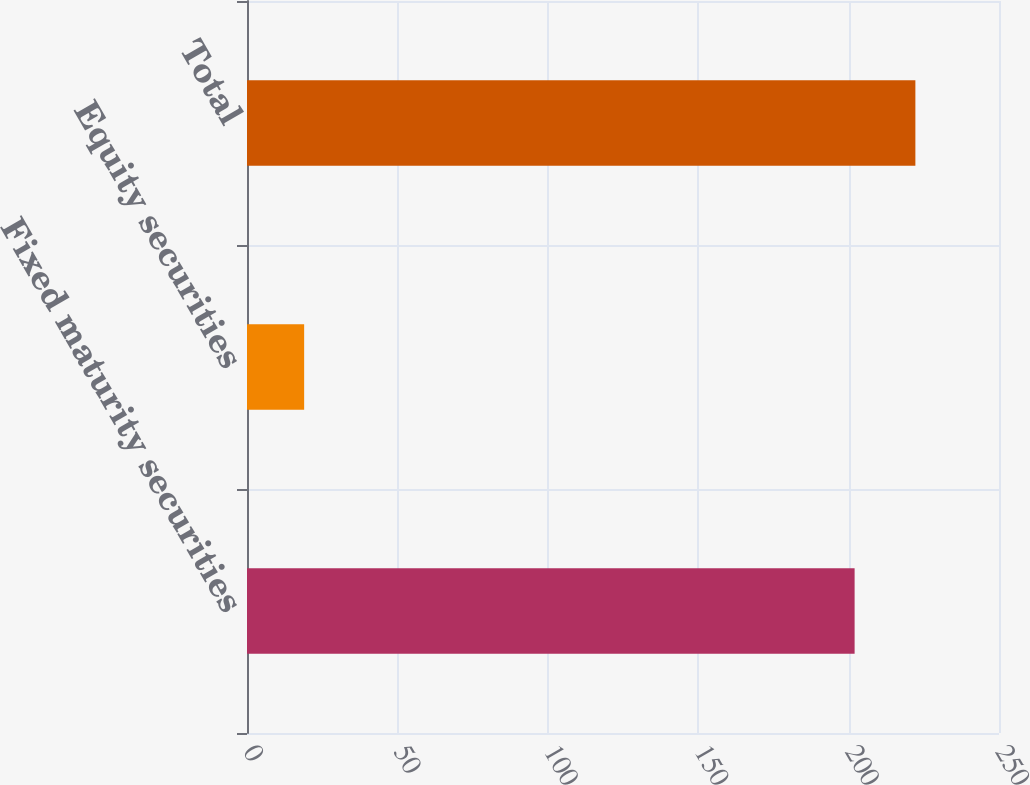Convert chart to OTSL. <chart><loc_0><loc_0><loc_500><loc_500><bar_chart><fcel>Fixed maturity securities<fcel>Equity securities<fcel>Total<nl><fcel>202<fcel>19<fcel>222.2<nl></chart> 